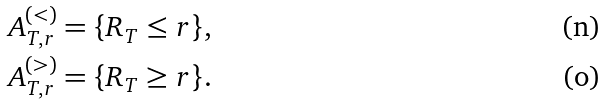<formula> <loc_0><loc_0><loc_500><loc_500>A ^ { ( < ) } _ { T , r } & = \{ R _ { T } \leq r \} , \\ A ^ { ( > ) } _ { T , r } & = \{ R _ { T } \geq r \} .</formula> 